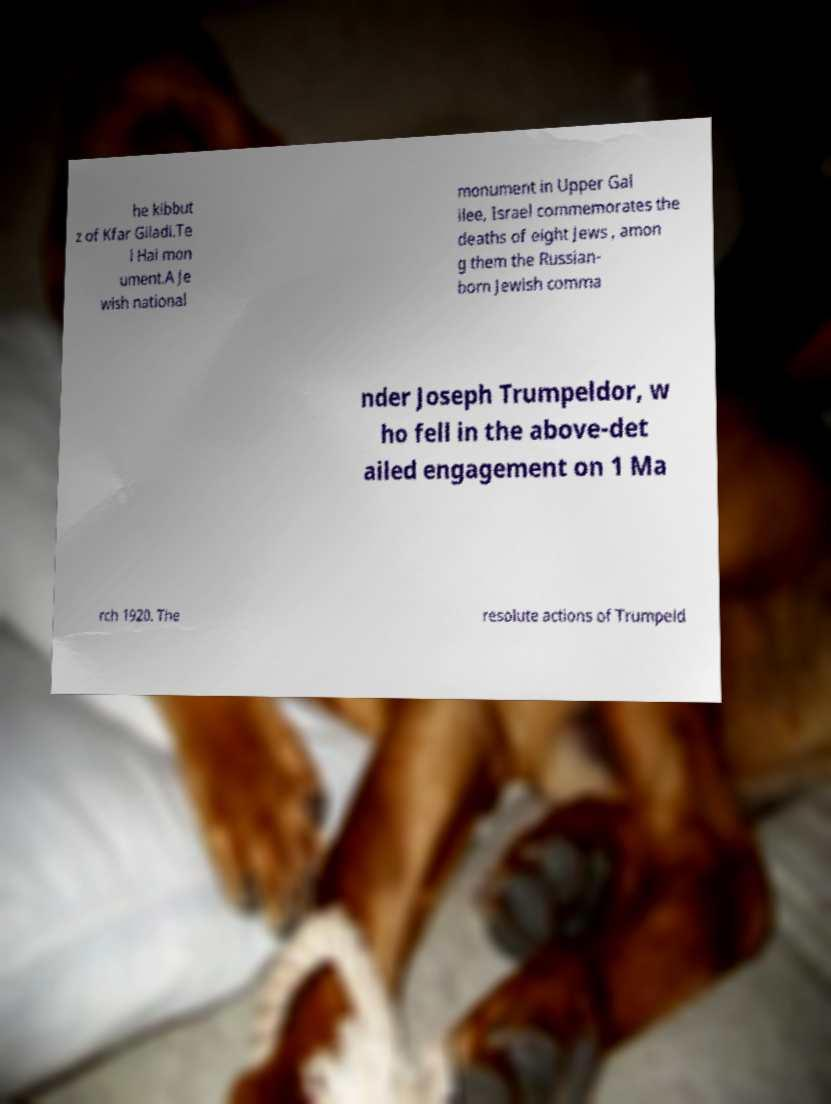Can you accurately transcribe the text from the provided image for me? he kibbut z of Kfar Giladi.Te l Hai mon ument.A Je wish national monument in Upper Gal ilee, Israel commemorates the deaths of eight Jews , amon g them the Russian- born Jewish comma nder Joseph Trumpeldor, w ho fell in the above-det ailed engagement on 1 Ma rch 1920. The resolute actions of Trumpeld 